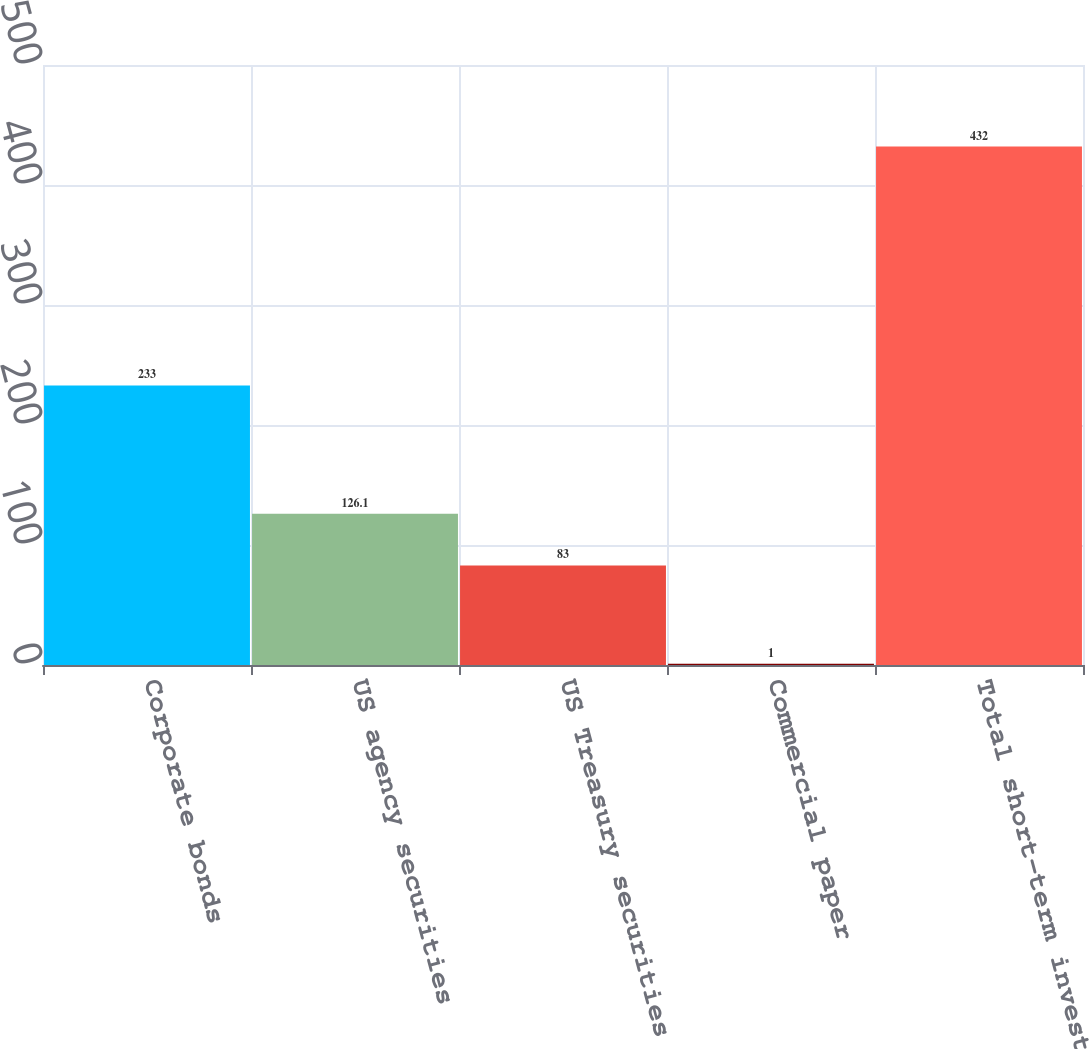<chart> <loc_0><loc_0><loc_500><loc_500><bar_chart><fcel>Corporate bonds<fcel>US agency securities<fcel>US Treasury securities<fcel>Commercial paper<fcel>Total short-term investments<nl><fcel>233<fcel>126.1<fcel>83<fcel>1<fcel>432<nl></chart> 